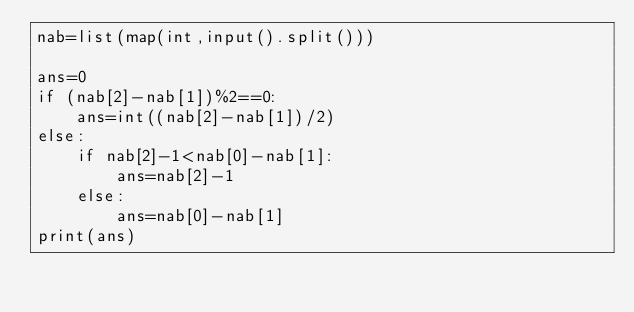Convert code to text. <code><loc_0><loc_0><loc_500><loc_500><_Python_>nab=list(map(int,input().split()))

ans=0
if (nab[2]-nab[1])%2==0:
    ans=int((nab[2]-nab[1])/2)
else:
    if nab[2]-1<nab[0]-nab[1]:
        ans=nab[2]-1
    else:
        ans=nab[0]-nab[1]
print(ans)
</code> 